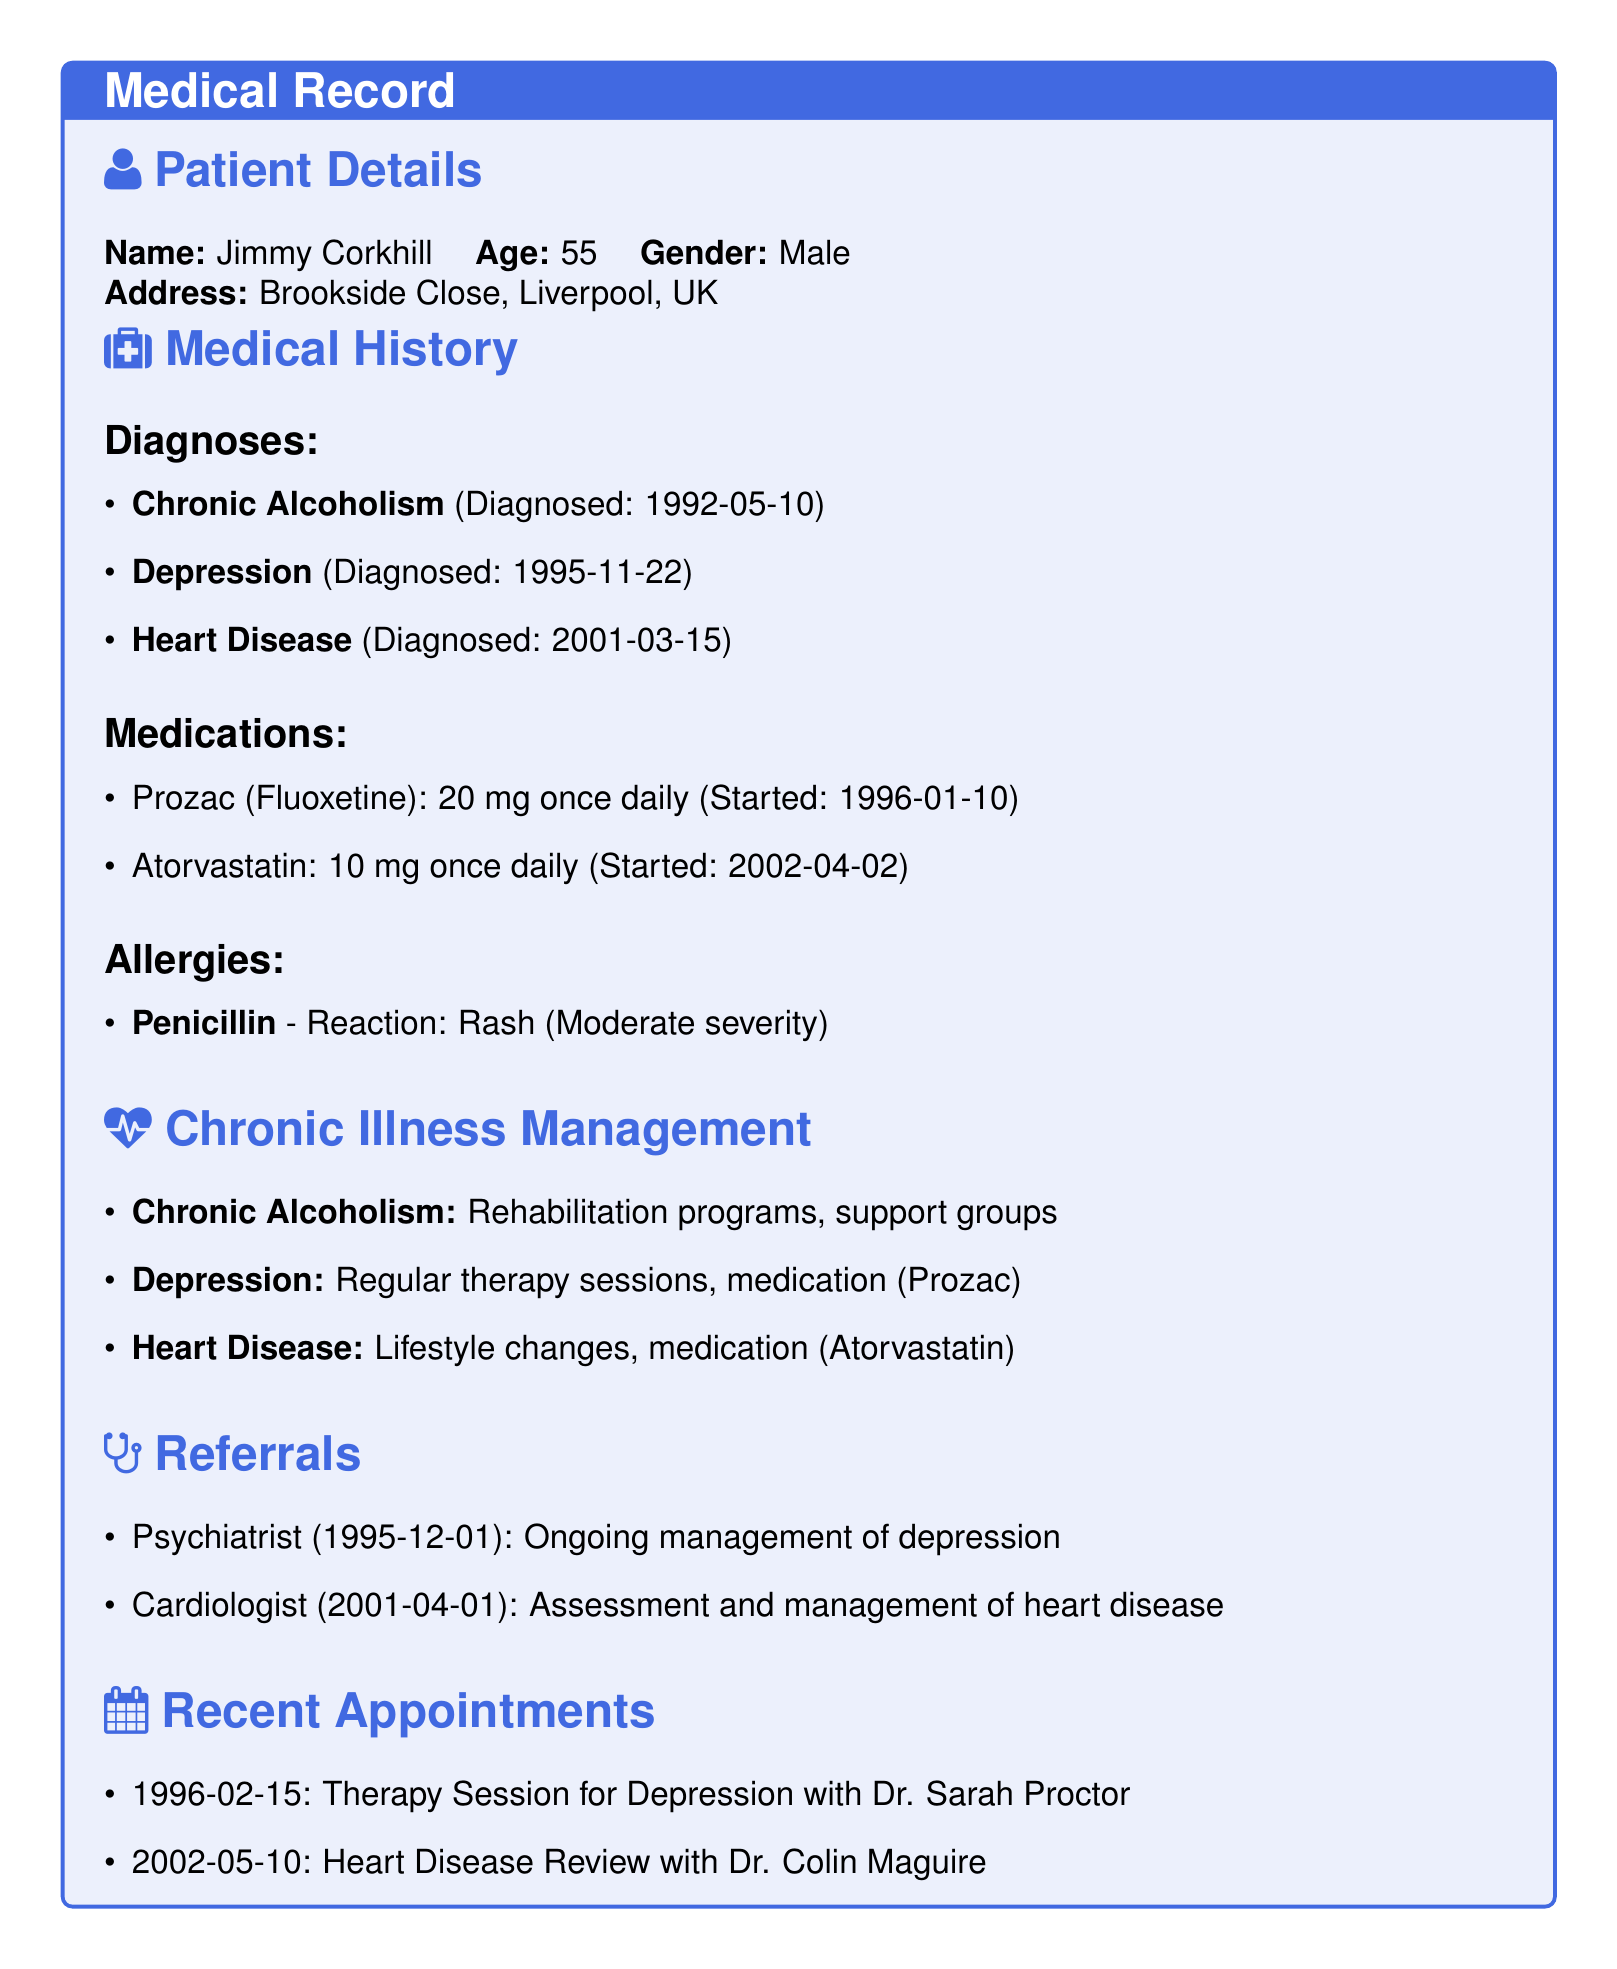What is the patient's name? The patient's name is explicitly listed in the document under Patient Details.
Answer: Jimmy Corkhill When was the chronic alcoholism diagnosed? The document states the date of diagnosis for chronic alcoholism in the Medical History section.
Answer: 1992-05-10 What medication is prescribed for depression? The document lists the medication prescribed for depression under the Medications section.
Answer: Prozac (Fluoxetine) How many recent appointments are listed? The number of recent appointments can be counted in the Recent Appointments section of the document.
Answer: 2 Who is the psychiatrist referred to? The document explicitly names the psychiatrist to whom Jimmy was referred for ongoing management of depression.
Answer: Dr. Sarah Proctor What lifestyle changes are mentioned for heart disease management? The document specifies lifestyle changes as part of heart disease management but does not detail them, requiring inference from the Chronic Illness Management section.
Answer: Lifestyle changes What is Jimmy's age? The age of the patient is explicitly mentioned in the Patient Details section.
Answer: 55 What reaction is noted for penicillin allergy? The document provides specific details about the patient's reaction to penicillin within the Allergies section.
Answer: Rash When was the heart disease review appointment? The date of the heart disease review appointment can be found in the Recent Appointments section.
Answer: 2002-05-10 